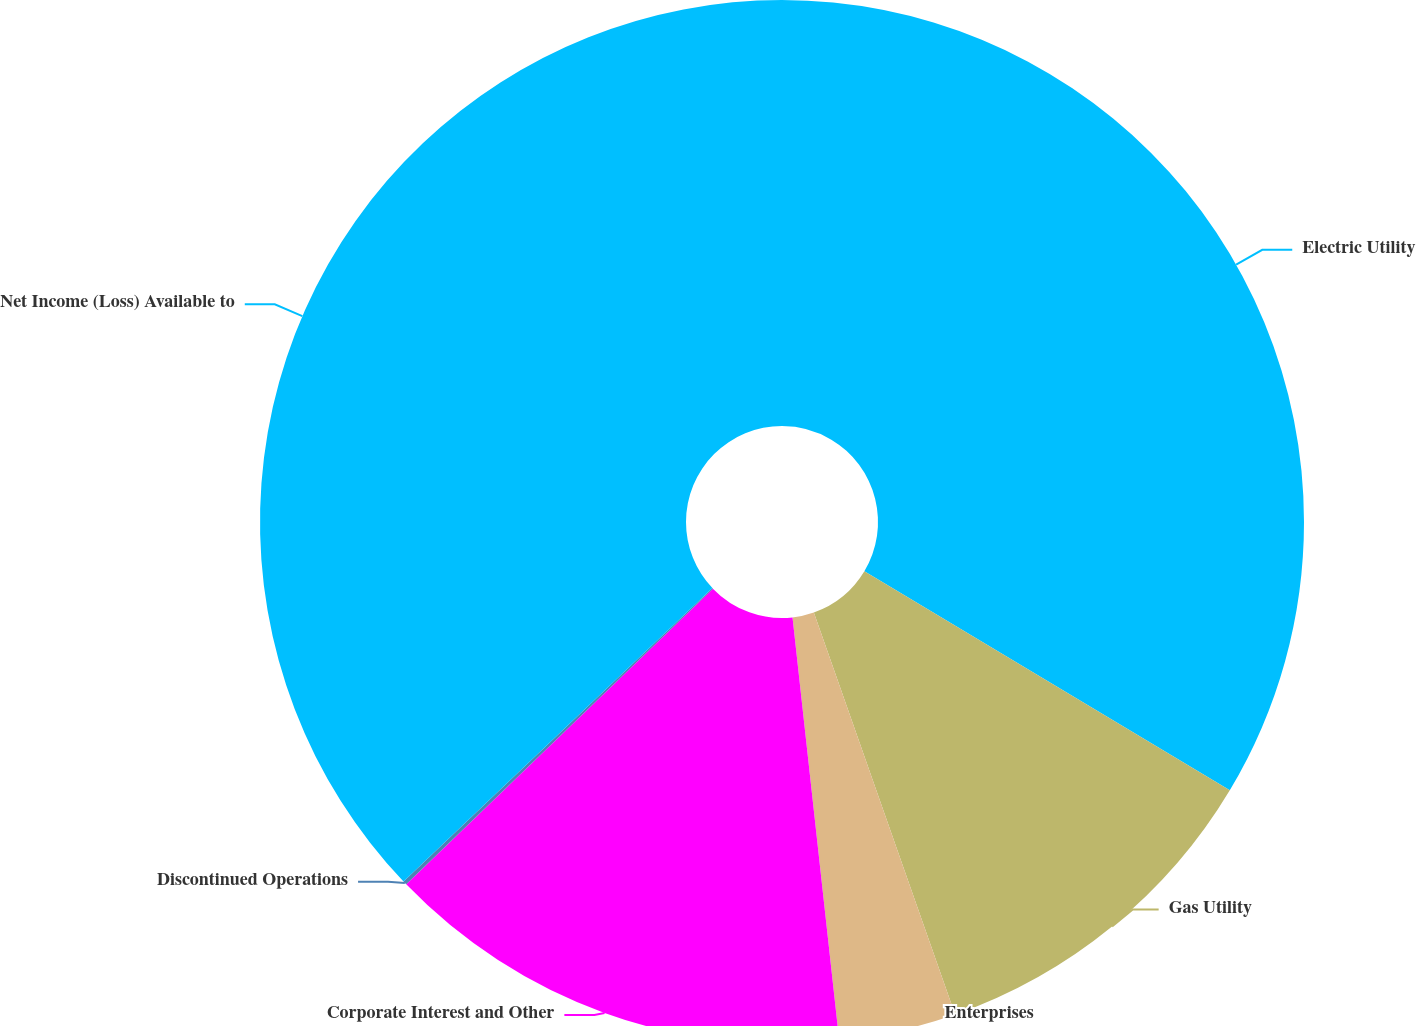<chart> <loc_0><loc_0><loc_500><loc_500><pie_chart><fcel>Electric Utility<fcel>Gas Utility<fcel>Enterprises<fcel>Corporate Interest and Other<fcel>Discontinued Operations<fcel>Net Income (Loss) Available to<nl><fcel>33.59%<fcel>11.03%<fcel>3.63%<fcel>14.54%<fcel>0.12%<fcel>37.09%<nl></chart> 